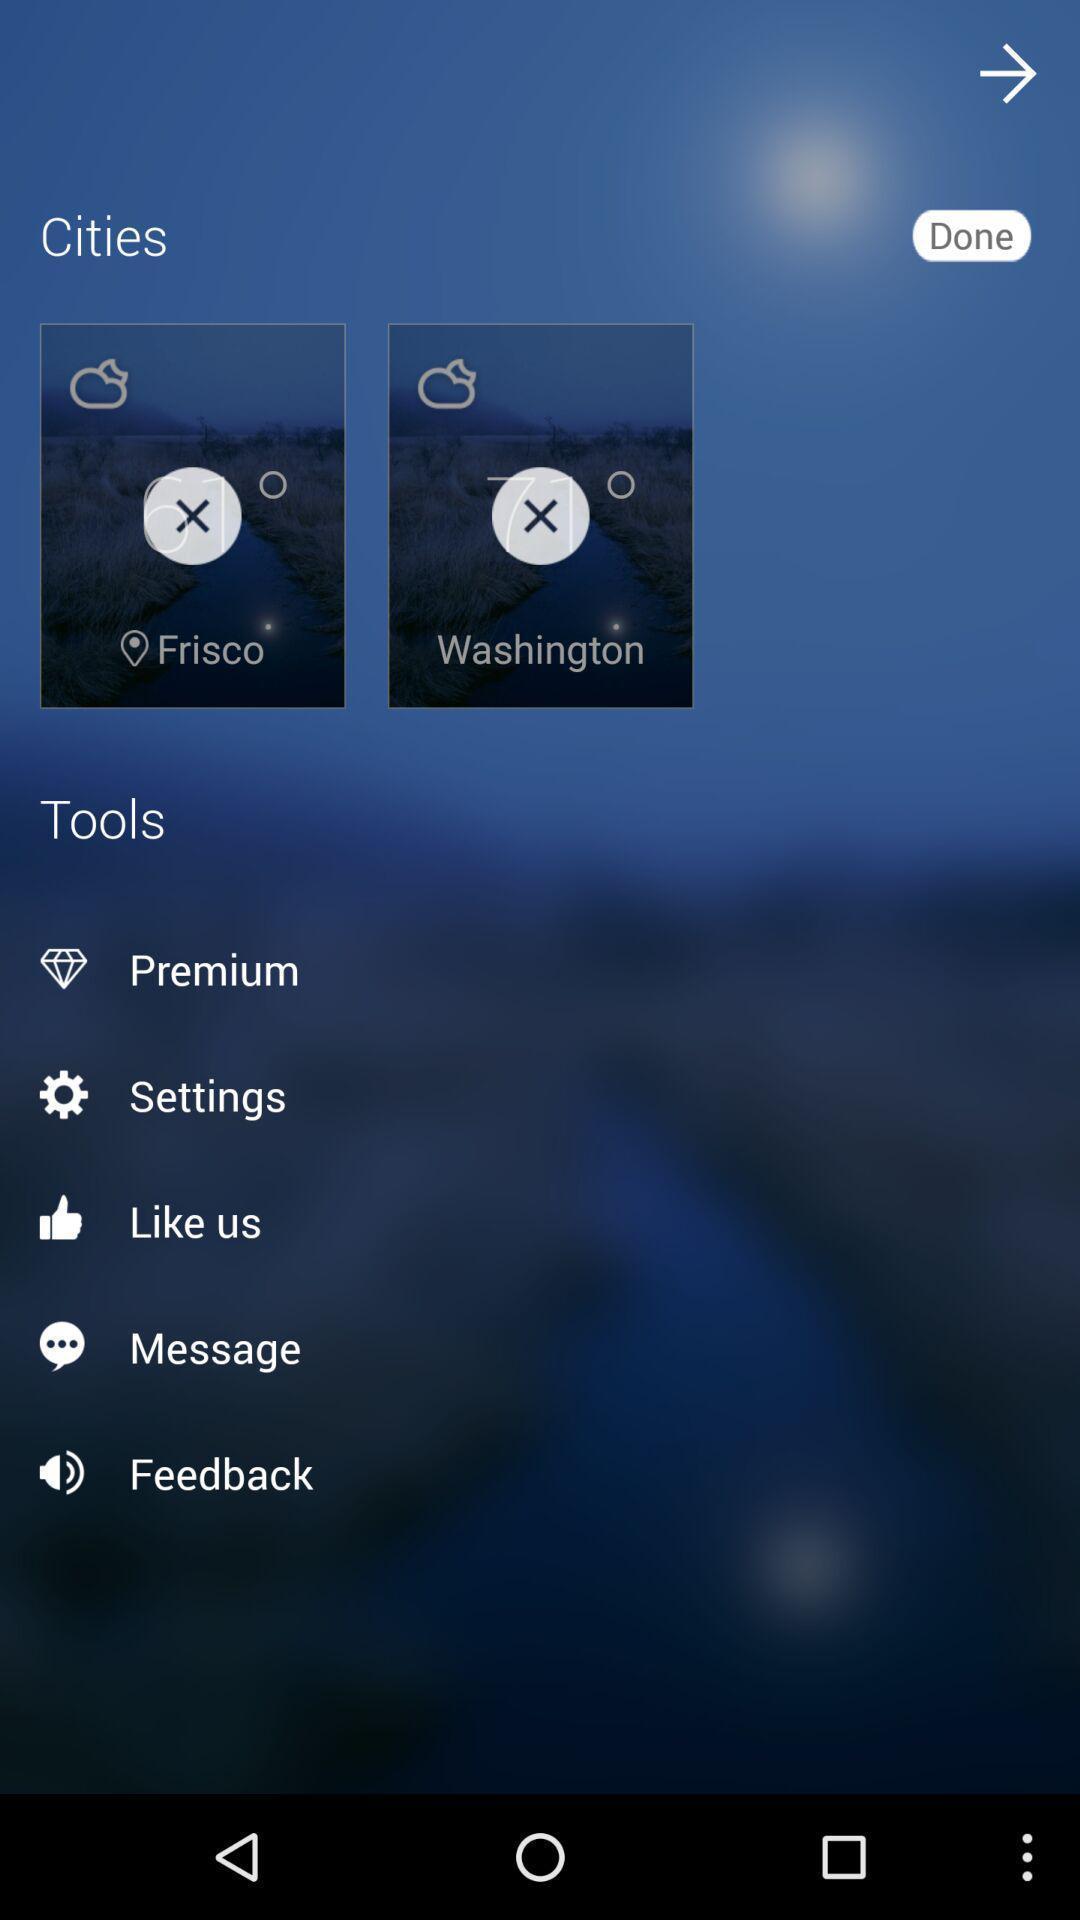Tell me about the visual elements in this screen capture. Settings page. 